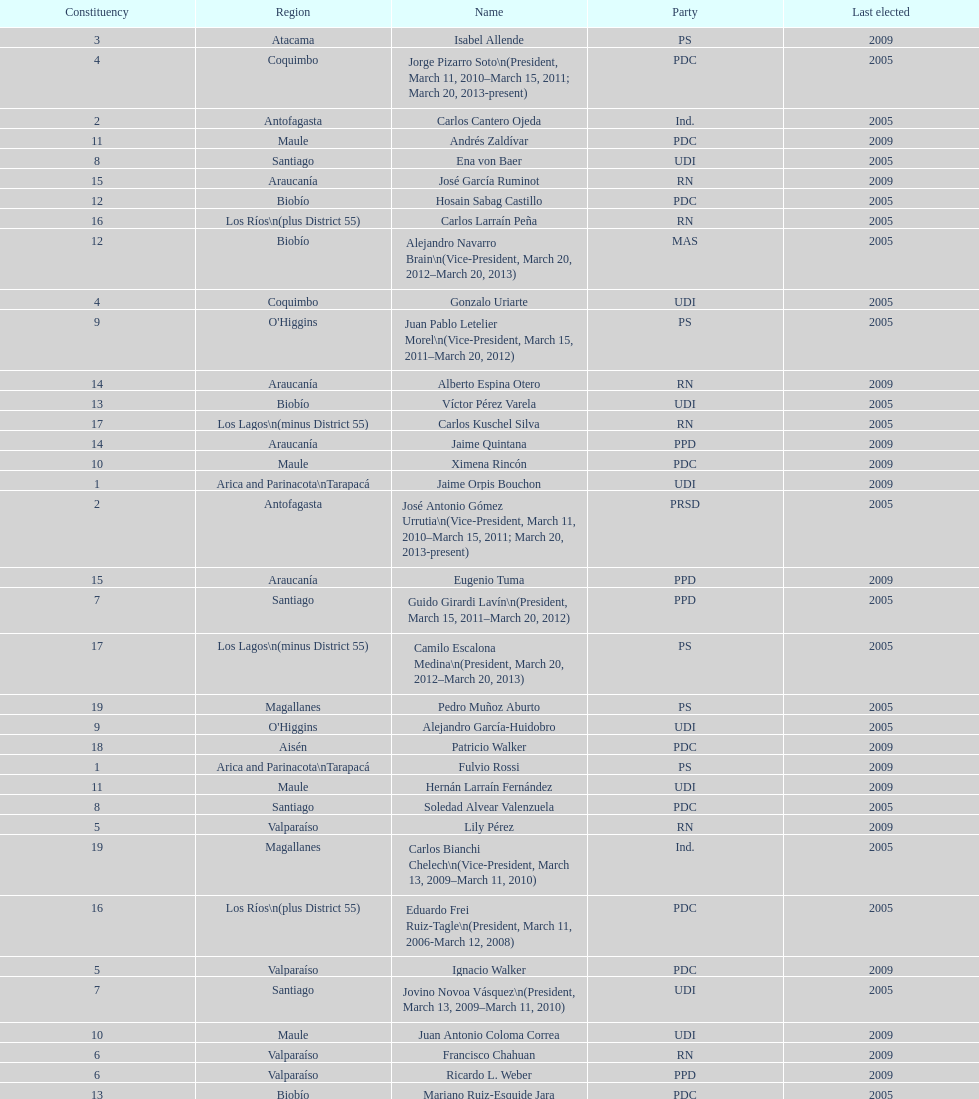Which party did jaime quintana belong to? PPD. 